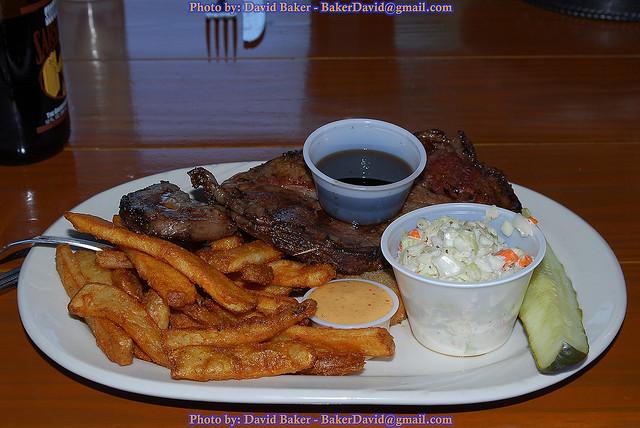How many forks are on the table?
Quick response, please. 1. What is for lunch?
Answer briefly. Steak and fries. What is on the plate?
Quick response, please. Food. What is the food in the foreground called?
Quick response, please. Fries. What is in the containers?
Keep it brief. Coleslaw. What vegetable does the tiny green food scrap on the right side come from?
Quick response, please. Cucumber. Is this meal healthy?
Be succinct. No. Is there bread on the table?
Short answer required. No. Is this all for one person?
Short answer required. Yes. When was the picture taken?
Be succinct. Night. What is floating in the dipping sauce?
Be succinct. Nothing. Do you need utensils to eat this?
Quick response, please. Yes. What utensil can be seen?
Keep it brief. Fork. Is this a healthy meal?
Give a very brief answer. No. What color is the table in this photo?
Be succinct. Brown. What kind of dipping sauce is in the metal cup?
Quick response, please. Soy. 